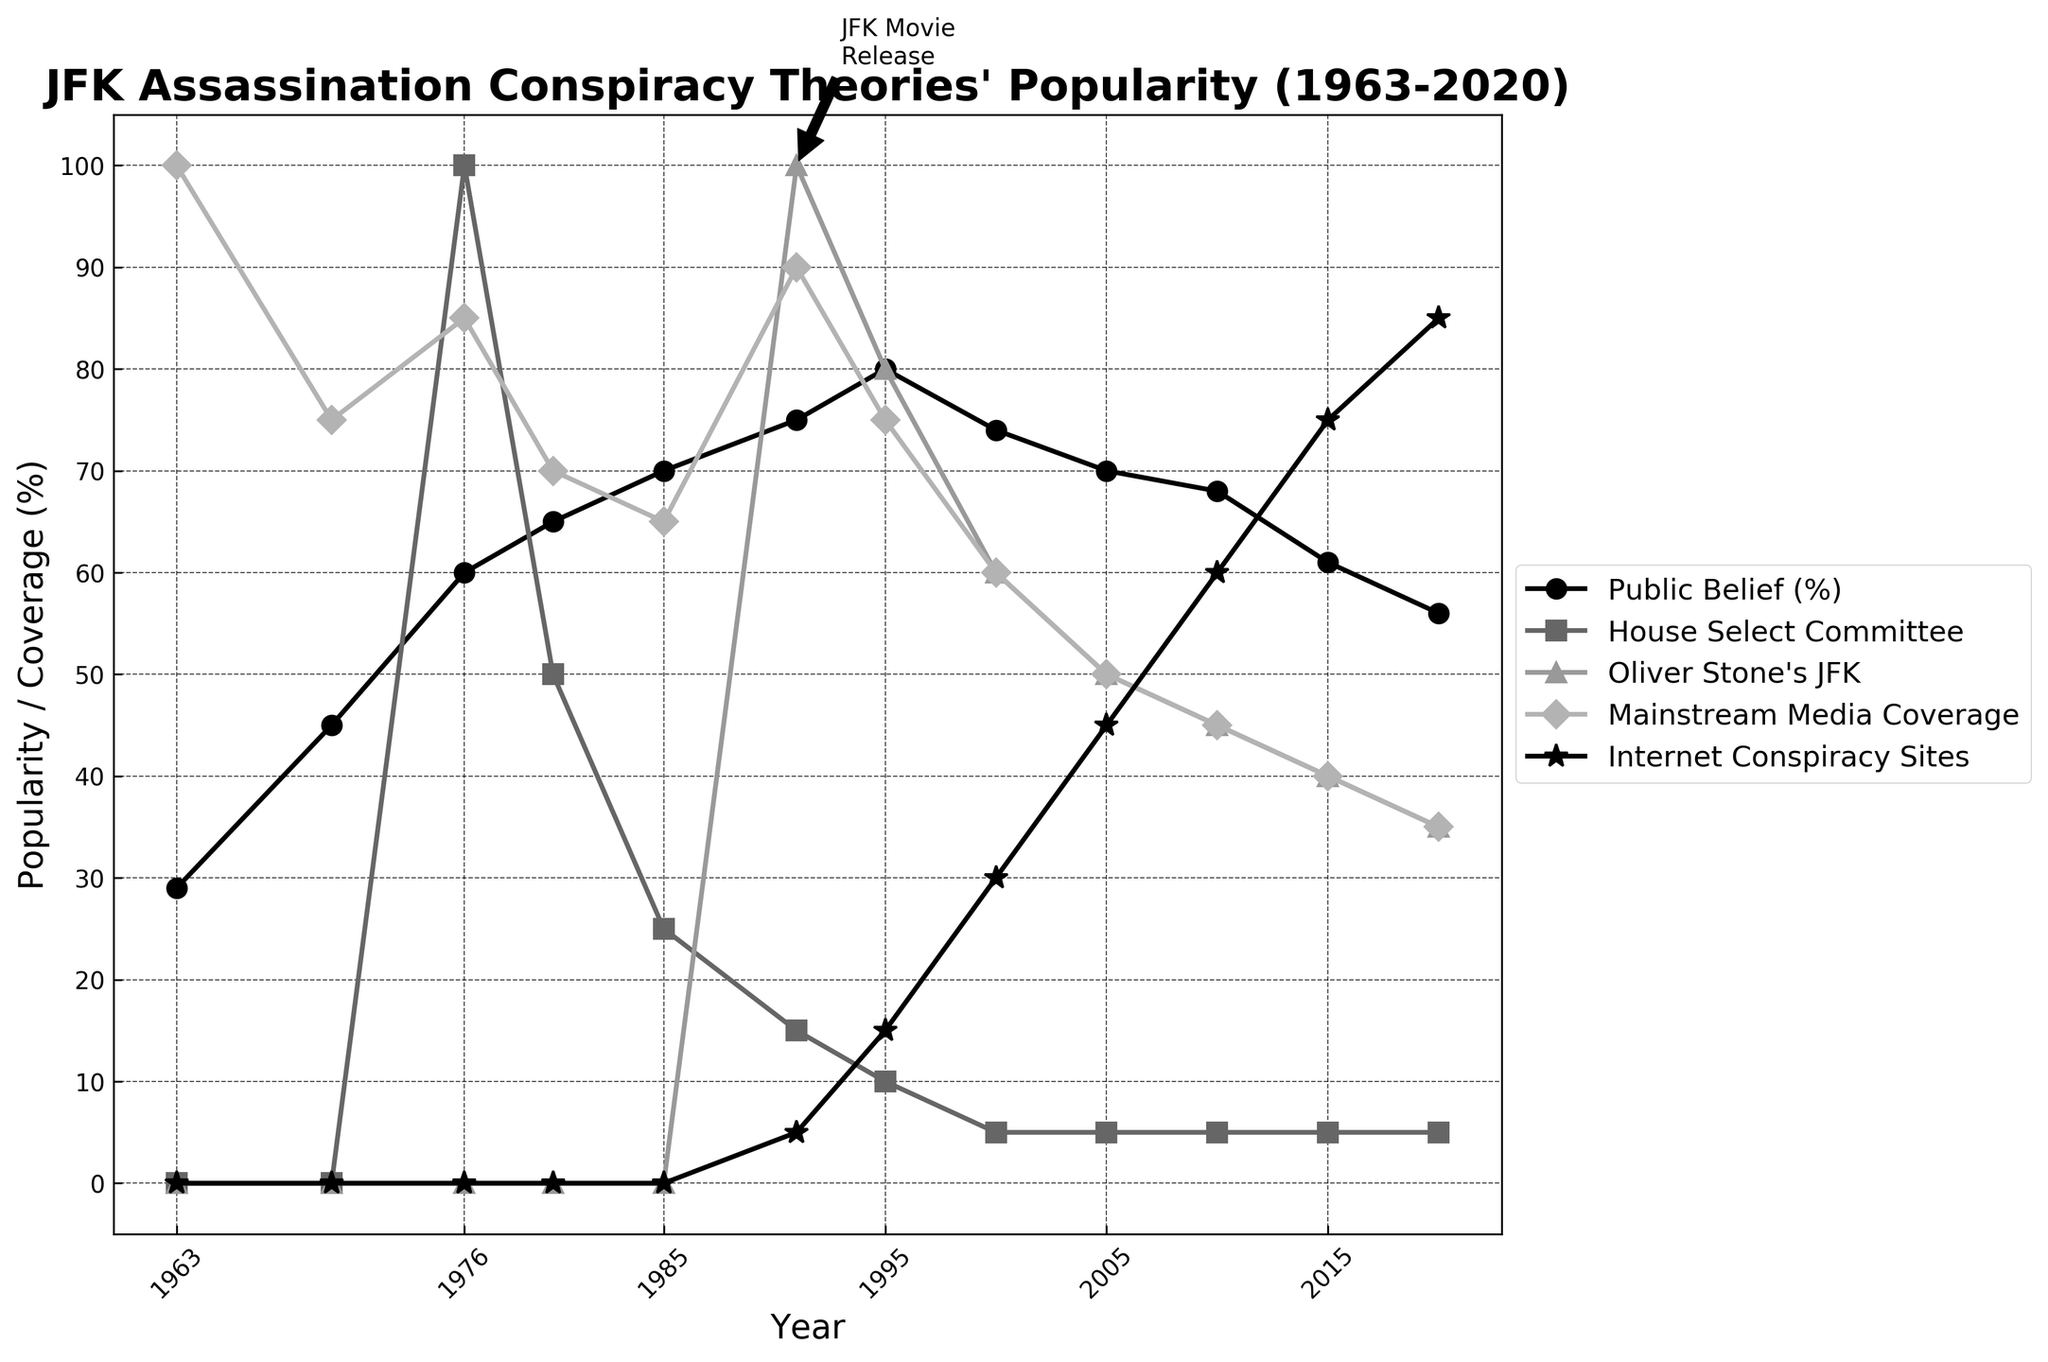What year did public belief in JFK assassination conspiracies peak? Look for the highest point along the 'Public Belief (%)' line. The peak is at 1995 with 80%.
Answer: 1995 How does the trend of public belief compare between 1963 and 2020? From the start at 29% in 1963 to the decrease to 56% in 2020, it shows an overall increase followed by a decline.
Answer: Increase then decrease Which category consistently shows the lowest values overall? Observing all categories' lines, 'House Select Committee' mostly shows the lowest values over time.
Answer: House Select Committee What significant event in the figure coincides with a peak in 'Oliver Stone's JFK'? The annotation points at 1991 when Oliver Stone's JFK film was released, which explains the spike in the ‘Oliver Stone’s JFK’ category.
Answer: Oliver Stone's JFK movie release Comparing 2000 and 2020, how has the popularity of internet conspiracy sites changed? Compare the points at these years for 'Internet Conspiracy Sites', 30% in 2000 and 85% in 2020, showing an increase.
Answer: Increased What is the difference between public belief in 1980 and 2010? Subtract the value at 2010 (68%) from that at 1980 (65%): 68 - 65 = 3%.
Answer: 3% What trend is noticeable for mainstream media coverage from 1963 to 2020? Look at the 'Mainstream Media Coverage' line. Initially, high at 100% in 1963, it generally declines to 35% by 2020.
Answer: Decline What two categories seem to have spikes around the release of Oliver Stone’s JFK? Observing the lines, both 'Public Belief (%)' and 'Oliver Stone’s JFK' show spikes around 1991.
Answer: Public Belief (%) and Oliver Stone’s JFK Which category saw the most dramatic increase between 2005 and 2020, aside from internet conspiracy sites? By comparing increases, 'Mainstream Media Coverage' shows a gradual decline, only 'Public Belief (%)' slightly decreases, hence 'Internet Conspiracy Sites' stands out with the most significant increase.
Answer: Internet Conspiracy Sites 